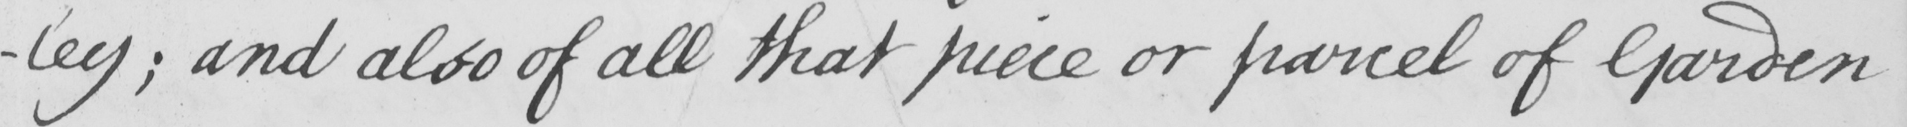Please provide the text content of this handwritten line. -ley ; and also of all that piece or parcel of Garden 